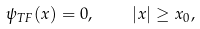Convert formula to latex. <formula><loc_0><loc_0><loc_500><loc_500>\psi _ { T F } ( x ) = 0 , \quad | x | \geq x _ { 0 } ,</formula> 